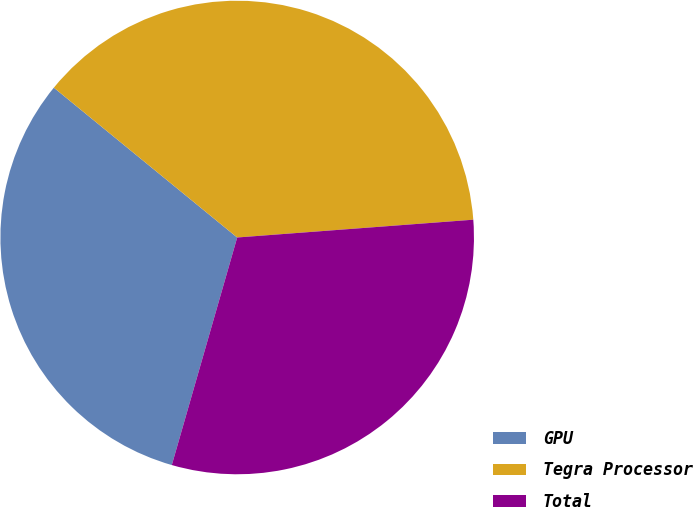Convert chart to OTSL. <chart><loc_0><loc_0><loc_500><loc_500><pie_chart><fcel>GPU<fcel>Tegra Processor<fcel>Total<nl><fcel>31.45%<fcel>37.9%<fcel>30.65%<nl></chart> 